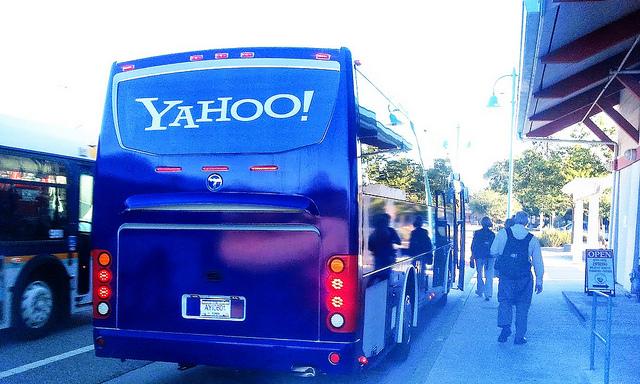What has the bus been written?
Write a very short answer. Yahoo. How many buses are in this picture?
Answer briefly. 2. What are the letters in the logo?
Short answer required. Yahoo. What is the website on the bus?
Keep it brief. Yahoo. Is there a reflection in the scene?
Answer briefly. Yes. 